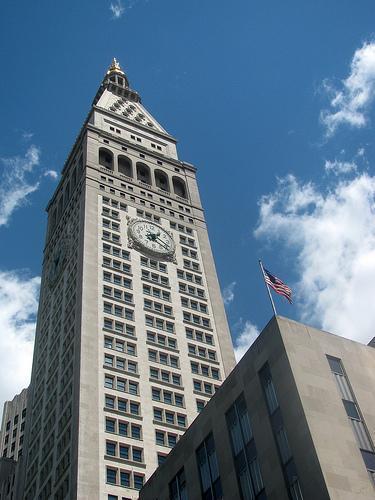How many flags are visible in the photo?
Give a very brief answer. 1. 